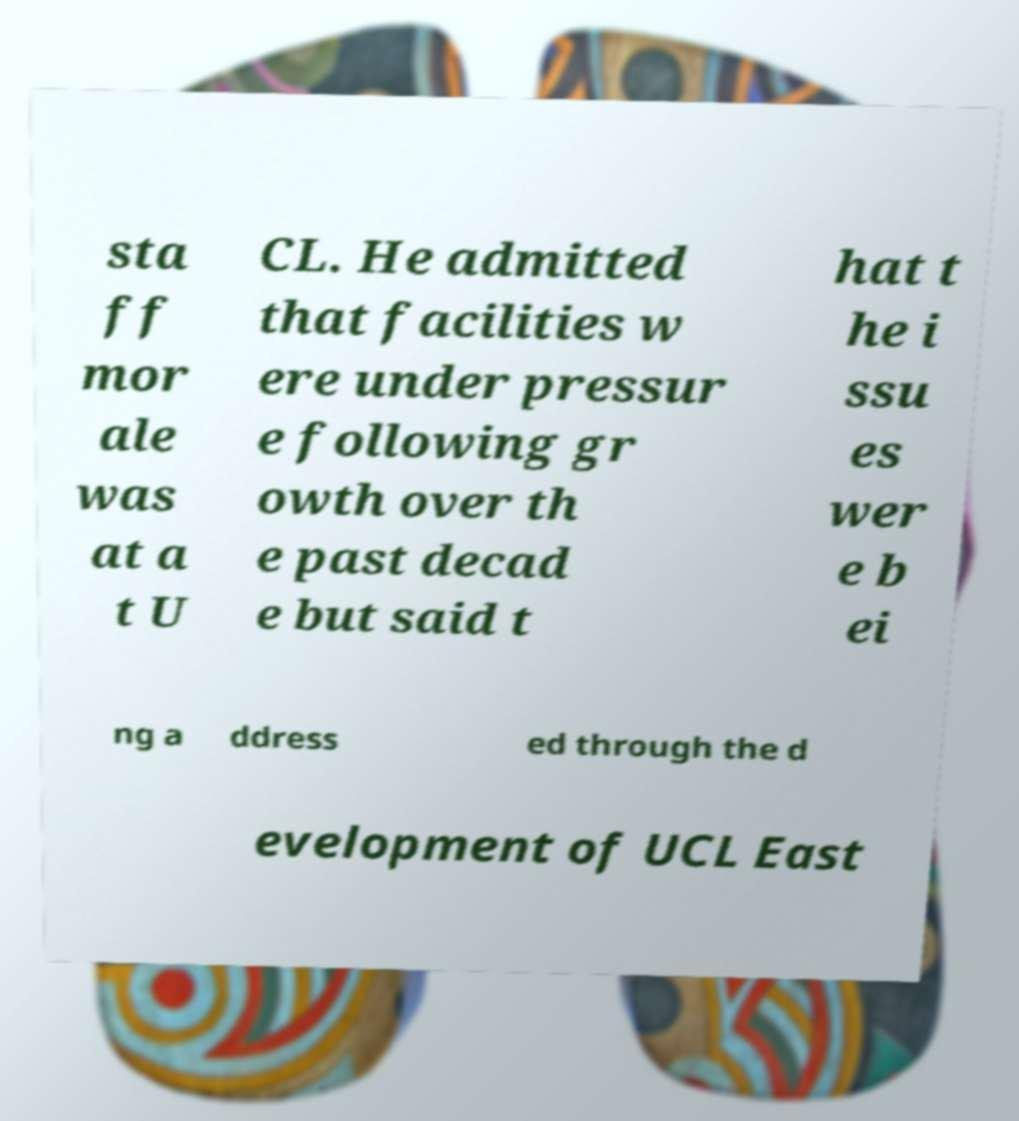There's text embedded in this image that I need extracted. Can you transcribe it verbatim? sta ff mor ale was at a t U CL. He admitted that facilities w ere under pressur e following gr owth over th e past decad e but said t hat t he i ssu es wer e b ei ng a ddress ed through the d evelopment of UCL East 